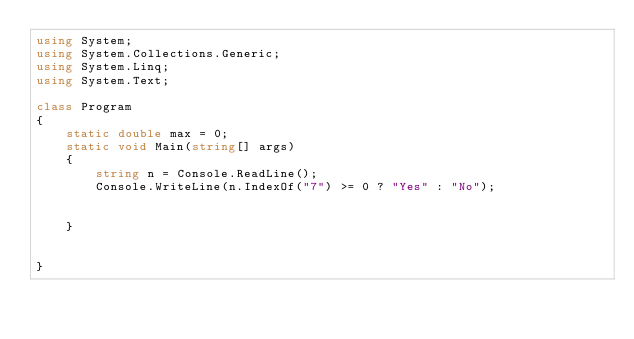<code> <loc_0><loc_0><loc_500><loc_500><_C#_>using System;
using System.Collections.Generic;
using System.Linq;
using System.Text;

class Program
{
    static double max = 0;
    static void Main(string[] args)
    {
        string n = Console.ReadLine();
        Console.WriteLine(n.IndexOf("7") >= 0 ? "Yes" : "No");


    }


}

</code> 